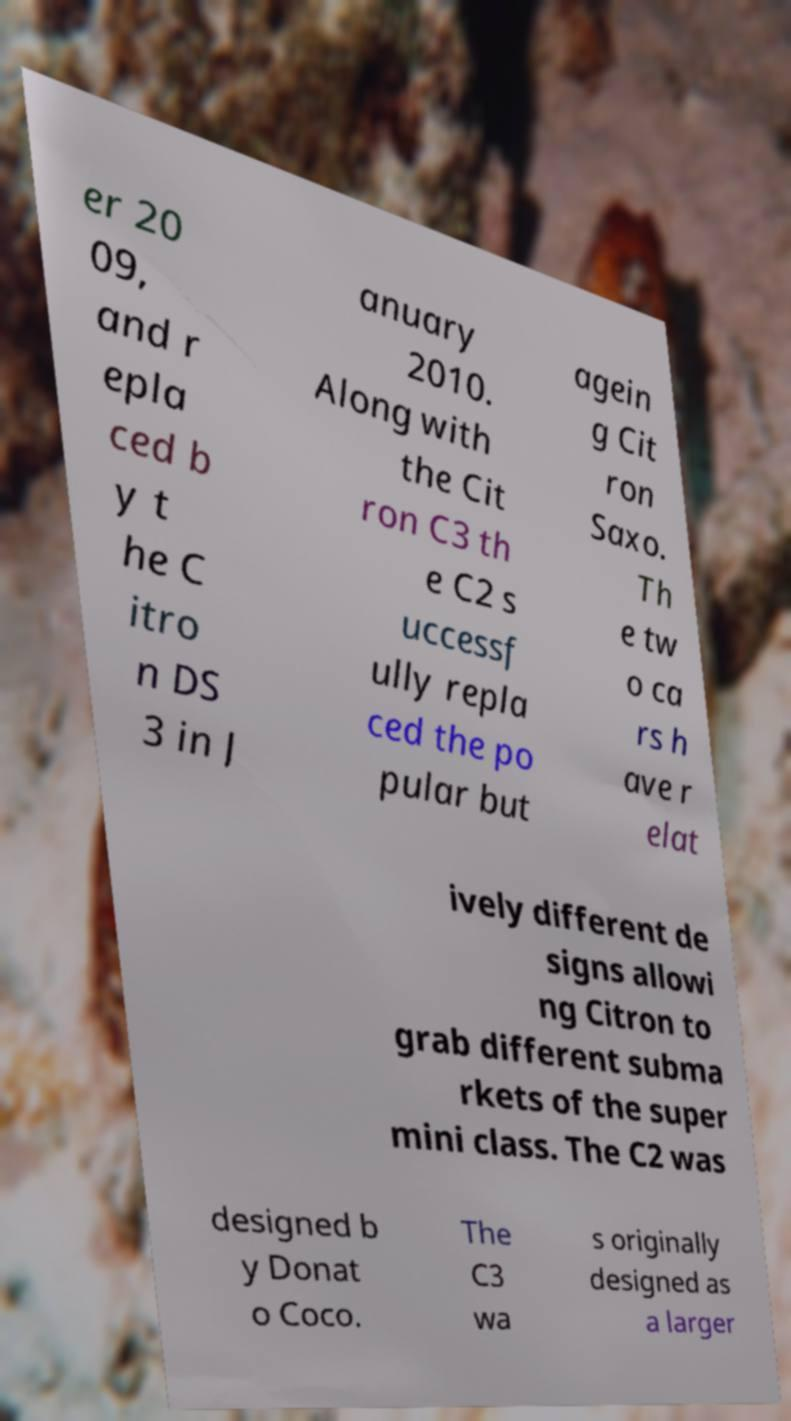There's text embedded in this image that I need extracted. Can you transcribe it verbatim? er 20 09, and r epla ced b y t he C itro n DS 3 in J anuary 2010. Along with the Cit ron C3 th e C2 s uccessf ully repla ced the po pular but agein g Cit ron Saxo. Th e tw o ca rs h ave r elat ively different de signs allowi ng Citron to grab different subma rkets of the super mini class. The C2 was designed b y Donat o Coco. The C3 wa s originally designed as a larger 